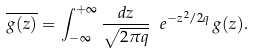<formula> <loc_0><loc_0><loc_500><loc_500>\overline { g ( z ) } = \int _ { - \infty } ^ { + \infty } \frac { d z } { \sqrt { 2 \pi q } } \ e ^ { - z ^ { 2 } / 2 q } \, g ( z ) .</formula> 